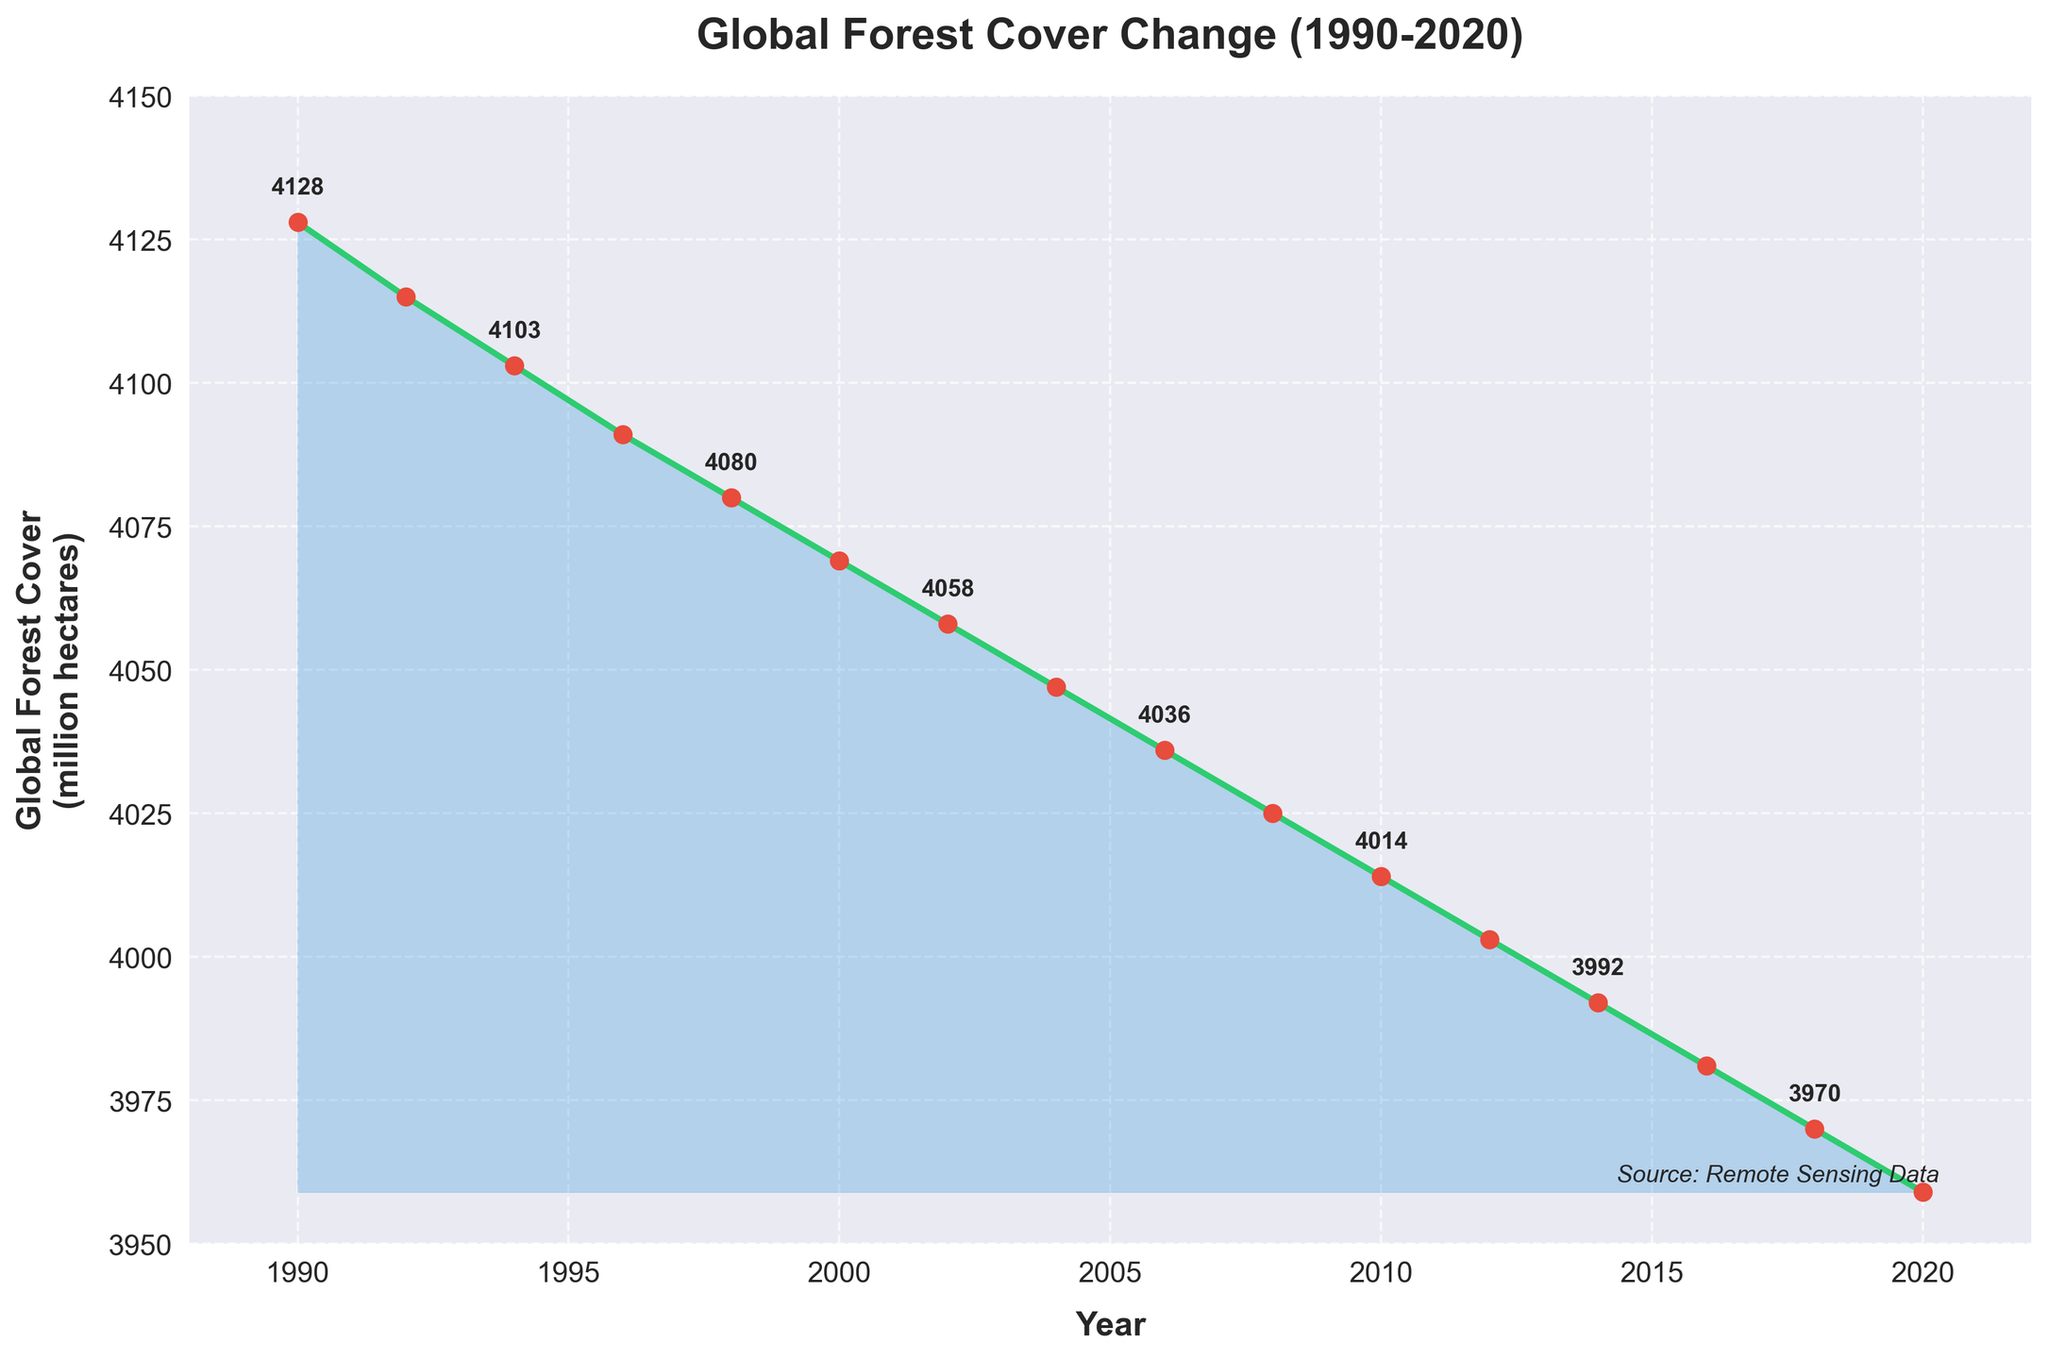What is the overall trend in global forest cover from 1990 to 2020? The plot shows a consistent downward trend in global forest cover from 4128 million hectares in 1990 to 3959 million hectares in 2020. This indicates a continuous reduction in forest cover over the examined period.
Answer: Continuous decrease Which year had the highest global forest cover? By examining the plot, the highest global forest cover occurs at the starting point in 1990 where the forest cover is 4128 million hectares.
Answer: 1990 What is the difference in global forest cover between 1990 and 2020? From the plot, global forest cover was 4128 million hectares in 1990 and 3959 million hectares in 2020. The difference is 4128 - 3959 = 169 million hectares.
Answer: 169 million hectares In which period did the global forest cover decline the most sharply? By analyzing the slope of the line, the sharpest decline appears to be between 1990 and 1992.
Answer: 1990-1992 What is the average loss of global forest cover per year over the 30-year span? To find the average annual loss, calculate the total loss over 30 years: 4128 - 3959 = 169. Dividing this total loss by the number of years (30), we get 169 / 30 ≈ 5.63 million hectares per year.
Answer: 5.63 million hectares per year How does the forest cover in 2000 compare to 2010? From the plot, forest cover in 2000 is 4069 million hectares, and in 2010, it is 4014 million hectares. The difference is 4069 - 4014 = 55 million hectares.
Answer: 55 million hectares less in 2010 By how much did global forest cover decrease from 1998 to 2002? From the plot, the forest cover in 1998 is 4080 million hectares and in 2002, it is 4058 million hectares. The decrease is 4080 - 4058 = 22 million hectares.
Answer: 22 million hectares At what years does the plot annotate the global forest cover values? The plot annotates values approximately every other year: 1990, 1994, 1998, 2002, 2006, 2010, 2014, and 2018.
Answer: 1990, 1994, 1998, 2002, 2006, 2010, 2014, 2018 What color is used to represent the global forest cover line, and what color is used for the markers on the plot? The line representing forest cover is green, while the markers on the plot are red.
Answer: Green line, red markers What is the global forest cover value in 2016 as annotated on the plot? The value annotated for the year 2016 on the plot shows a forest cover of 3981 million hectares.
Answer: 3981 million hectares 